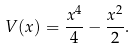Convert formula to latex. <formula><loc_0><loc_0><loc_500><loc_500>V ( x ) = \frac { x ^ { 4 } } { 4 } - \frac { x ^ { 2 } } 2 .</formula> 